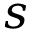<formula> <loc_0><loc_0><loc_500><loc_500>s</formula> 